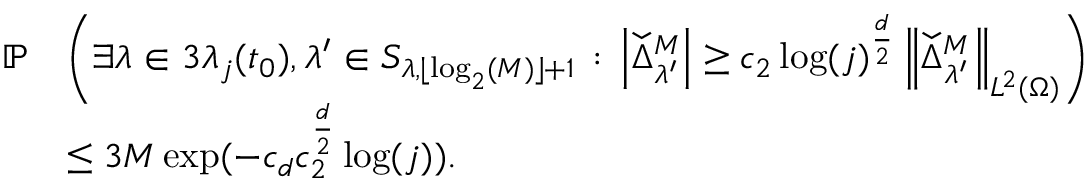Convert formula to latex. <formula><loc_0><loc_0><loc_500><loc_500>\begin{array} { r l } { \mathbb { P } } & { \left ( \exists \lambda \in 3 \lambda _ { j } ( t _ { 0 } ) , \lambda ^ { \prime } \in S _ { \lambda , \lfloor \log _ { 2 } ( M ) \rfloor + 1 } \, \colon \, \left | \ w i d e c h e c k { \Delta } _ { \lambda ^ { \prime } } ^ { M } \right | \geq c _ { 2 } \log ( j ) ^ { \frac { d } { 2 } } \left \| \ w i d e c h e c k { \Delta } _ { \lambda ^ { \prime } } ^ { M } \right \| _ { L ^ { 2 } ( \Omega ) } \right ) } \\ & { \leq 3 M \exp ( - c _ { d } c _ { 2 } ^ { \frac { d } { 2 } } \log ( j ) ) . } \end{array}</formula> 